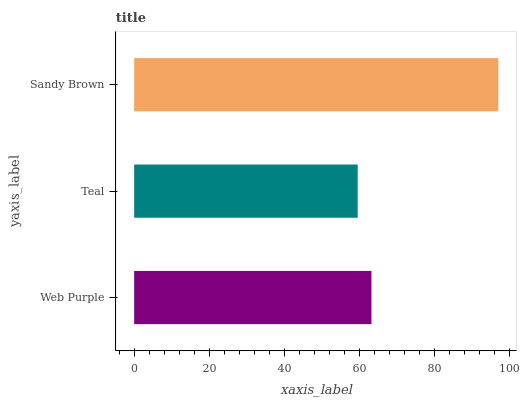Is Teal the minimum?
Answer yes or no. Yes. Is Sandy Brown the maximum?
Answer yes or no. Yes. Is Sandy Brown the minimum?
Answer yes or no. No. Is Teal the maximum?
Answer yes or no. No. Is Sandy Brown greater than Teal?
Answer yes or no. Yes. Is Teal less than Sandy Brown?
Answer yes or no. Yes. Is Teal greater than Sandy Brown?
Answer yes or no. No. Is Sandy Brown less than Teal?
Answer yes or no. No. Is Web Purple the high median?
Answer yes or no. Yes. Is Web Purple the low median?
Answer yes or no. Yes. Is Sandy Brown the high median?
Answer yes or no. No. Is Sandy Brown the low median?
Answer yes or no. No. 